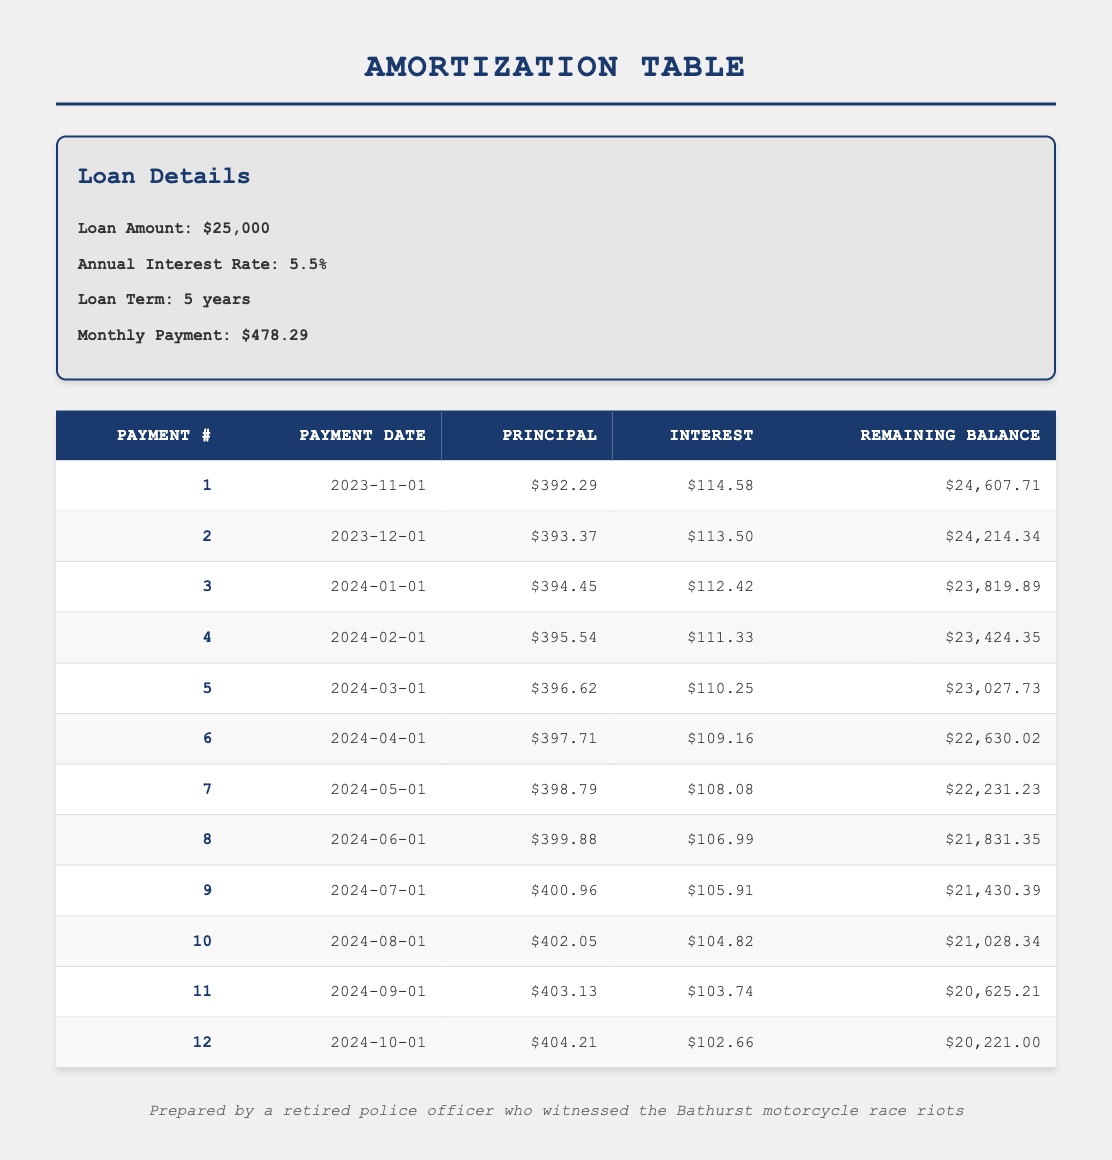What is the total amount paid in the first 12 months? To calculate the total paid in the first 12 months, we need to sum the monthly payments for each of the 12 months. Since the monthly payment is consistent at $478.29, we simply multiply $478.29 by 12, giving us $5,739.48.
Answer: 5,739.48 How much of the loan principal is paid off after the first 6 months? We need to sum the principal payments from the first 6 months listed in the table. The principal payments are: 392.29, 393.37, 394.45, 395.54, 396.62, and 397.71. Adding these values gives us (392.29 + 393.37 + 394.45 + 395.54 + 396.62 + 397.71) = 2,169.98.
Answer: 2,169.98 Is the interest payment decreasing with each payment? By reviewing the interest payments for each of the 12 months, we can see that they start at 114.58 and decrease to 102.66. This indicates that the interest payment is indeed decreasing over time.
Answer: Yes What is the remaining balance after the first payment? The remaining balance after the first payment is provided in the table as 24,607.71, directly following the first payment details.
Answer: 24,607.71 What is the average principal payment over the first 12 months? To find the average principal payment, we need to sum the principal payments of the first 12 months then divide by 12. The principal amounts total (392.29 + 393.37 + 394.45 + 395.54 + 396.62 + 397.71 + 398.79 + 399.88 + 400.96 + 402.05 + 403.13 + 404.21) = 4,769.75. Dividing this sum by 12 yields an average of 397.48.
Answer: 397.48 How much was paid only towards interest in the second month? To find out the interest paid in the second month, we refer to the table where the interest payment for the second month is specifically listed as 113.50.
Answer: 113.50 What is the difference in principal payment between the first and the last payments of the first year? The principal payment in the first month is 392.29 and in the last month (the 12th payment) is 404.21. The difference is calculated as 404.21 - 392.29 = 11.92.
Answer: 11.92 After how many payments will the remaining balance be below 20,000? By checking the remaining balance column, we can see that the remaining balance drops below 20,000 after the 12th payment (20,221.00), so it’s after the 12th payment that it will be under 20,000, but we need to find the exact payment. Continuing to look forward reveals after the 13th or 14th payment we would come in under 20,000. A closer look determines it goes below 20,000 after the 12th payment.
Answer: 12 